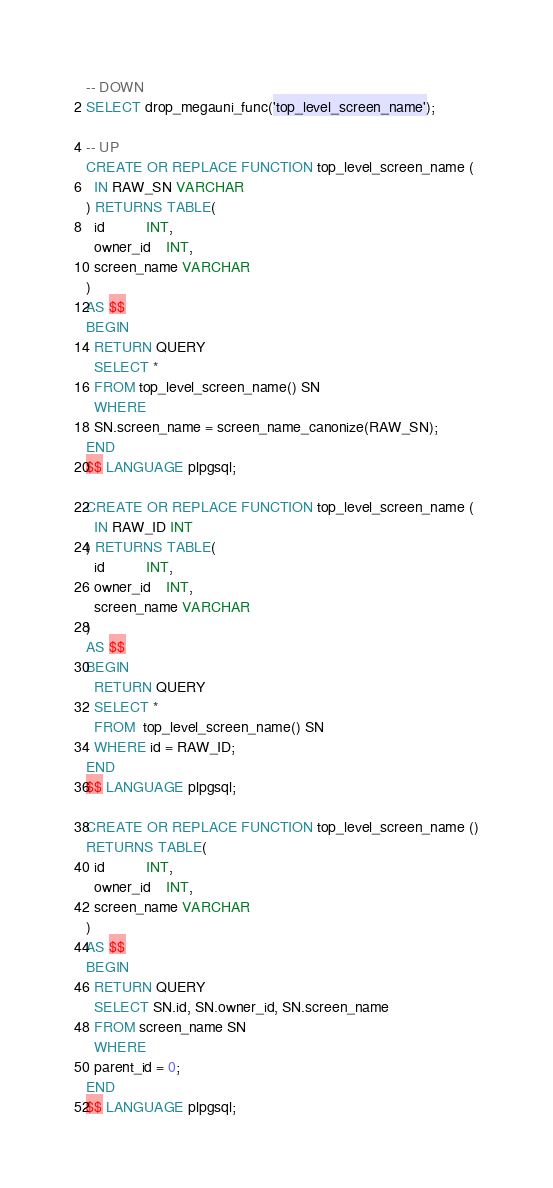<code> <loc_0><loc_0><loc_500><loc_500><_SQL_>
-- DOWN
SELECT drop_megauni_func('top_level_screen_name');

-- UP
CREATE OR REPLACE FUNCTION top_level_screen_name (
  IN RAW_SN VARCHAR
) RETURNS TABLE(
  id          INT,
  owner_id    INT,
  screen_name VARCHAR
)
AS $$
BEGIN
  RETURN QUERY
  SELECT *
  FROM top_level_screen_name() SN
  WHERE
  SN.screen_name = screen_name_canonize(RAW_SN);
END
$$ LANGUAGE plpgsql;

CREATE OR REPLACE FUNCTION top_level_screen_name (
  IN RAW_ID INT
) RETURNS TABLE(
  id          INT,
  owner_id    INT,
  screen_name VARCHAR
)
AS $$
BEGIN
  RETURN QUERY
  SELECT *
  FROM  top_level_screen_name() SN
  WHERE id = RAW_ID;
END
$$ LANGUAGE plpgsql;

CREATE OR REPLACE FUNCTION top_level_screen_name ()
RETURNS TABLE(
  id          INT,
  owner_id    INT,
  screen_name VARCHAR
)
AS $$
BEGIN
  RETURN QUERY
  SELECT SN.id, SN.owner_id, SN.screen_name
  FROM screen_name SN
  WHERE
  parent_id = 0;
END
$$ LANGUAGE plpgsql;
</code> 